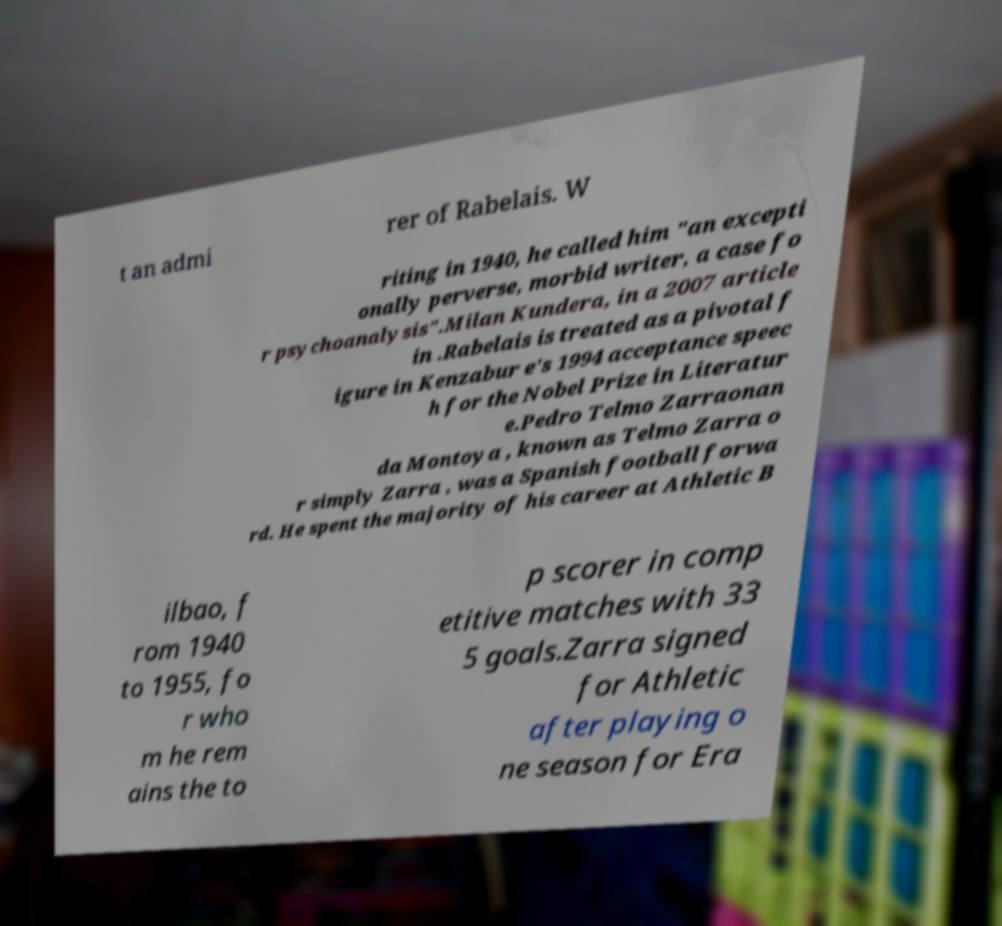For documentation purposes, I need the text within this image transcribed. Could you provide that? t an admi rer of Rabelais. W riting in 1940, he called him "an excepti onally perverse, morbid writer, a case fo r psychoanalysis".Milan Kundera, in a 2007 article in .Rabelais is treated as a pivotal f igure in Kenzabur e's 1994 acceptance speec h for the Nobel Prize in Literatur e.Pedro Telmo Zarraonan da Montoya , known as Telmo Zarra o r simply Zarra , was a Spanish football forwa rd. He spent the majority of his career at Athletic B ilbao, f rom 1940 to 1955, fo r who m he rem ains the to p scorer in comp etitive matches with 33 5 goals.Zarra signed for Athletic after playing o ne season for Era 